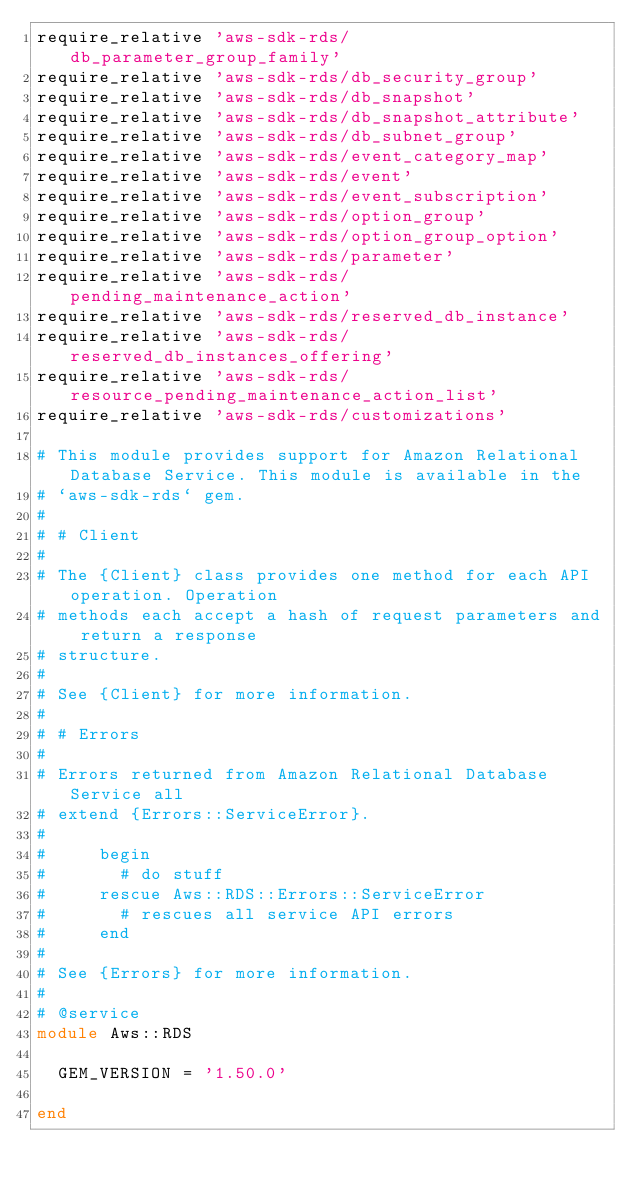Convert code to text. <code><loc_0><loc_0><loc_500><loc_500><_Ruby_>require_relative 'aws-sdk-rds/db_parameter_group_family'
require_relative 'aws-sdk-rds/db_security_group'
require_relative 'aws-sdk-rds/db_snapshot'
require_relative 'aws-sdk-rds/db_snapshot_attribute'
require_relative 'aws-sdk-rds/db_subnet_group'
require_relative 'aws-sdk-rds/event_category_map'
require_relative 'aws-sdk-rds/event'
require_relative 'aws-sdk-rds/event_subscription'
require_relative 'aws-sdk-rds/option_group'
require_relative 'aws-sdk-rds/option_group_option'
require_relative 'aws-sdk-rds/parameter'
require_relative 'aws-sdk-rds/pending_maintenance_action'
require_relative 'aws-sdk-rds/reserved_db_instance'
require_relative 'aws-sdk-rds/reserved_db_instances_offering'
require_relative 'aws-sdk-rds/resource_pending_maintenance_action_list'
require_relative 'aws-sdk-rds/customizations'

# This module provides support for Amazon Relational Database Service. This module is available in the
# `aws-sdk-rds` gem.
#
# # Client
#
# The {Client} class provides one method for each API operation. Operation
# methods each accept a hash of request parameters and return a response
# structure.
#
# See {Client} for more information.
#
# # Errors
#
# Errors returned from Amazon Relational Database Service all
# extend {Errors::ServiceError}.
#
#     begin
#       # do stuff
#     rescue Aws::RDS::Errors::ServiceError
#       # rescues all service API errors
#     end
#
# See {Errors} for more information.
#
# @service
module Aws::RDS

  GEM_VERSION = '1.50.0'

end
</code> 